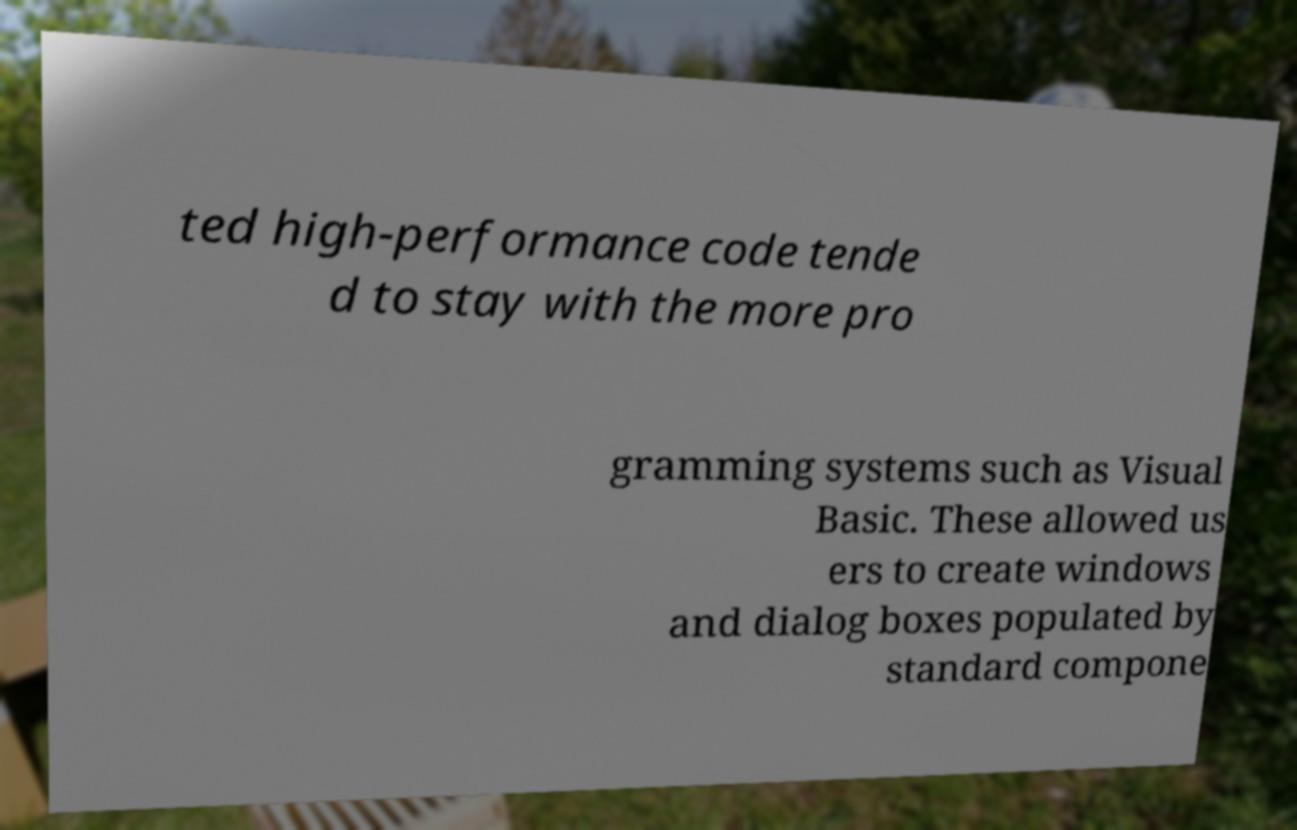For documentation purposes, I need the text within this image transcribed. Could you provide that? ted high-performance code tende d to stay with the more pro gramming systems such as Visual Basic. These allowed us ers to create windows and dialog boxes populated by standard compone 